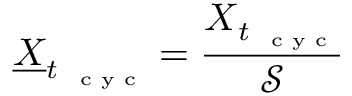Convert formula to latex. <formula><loc_0><loc_0><loc_500><loc_500>\underline { \boldsymbol X } _ { t _ { c y c } } = \frac { \boldsymbol X _ { t _ { c y c } } } { \mathcal { S } }</formula> 